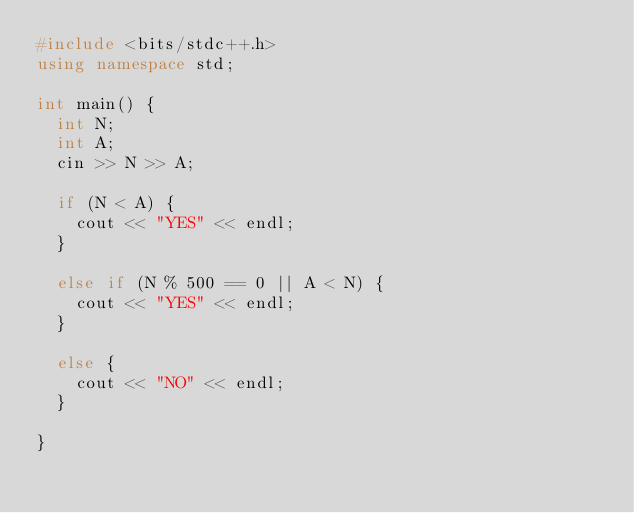Convert code to text. <code><loc_0><loc_0><loc_500><loc_500><_C++_>#include <bits/stdc++.h>
using namespace std;

int main() {
  int N;
  int A;
  cin >> N >> A;
  
  if (N < A) {
    cout << "YES" << endl;
  }
  
  else if (N % 500 == 0 || A < N) {
    cout << "YES" << endl;
  }
  
  else {
    cout << "NO" << endl;
  }
  
}</code> 